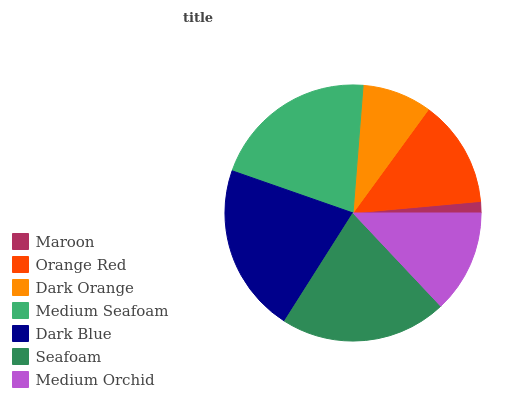Is Maroon the minimum?
Answer yes or no. Yes. Is Dark Blue the maximum?
Answer yes or no. Yes. Is Orange Red the minimum?
Answer yes or no. No. Is Orange Red the maximum?
Answer yes or no. No. Is Orange Red greater than Maroon?
Answer yes or no. Yes. Is Maroon less than Orange Red?
Answer yes or no. Yes. Is Maroon greater than Orange Red?
Answer yes or no. No. Is Orange Red less than Maroon?
Answer yes or no. No. Is Orange Red the high median?
Answer yes or no. Yes. Is Orange Red the low median?
Answer yes or no. Yes. Is Medium Seafoam the high median?
Answer yes or no. No. Is Seafoam the low median?
Answer yes or no. No. 